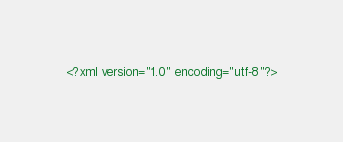<code> <loc_0><loc_0><loc_500><loc_500><_XML_><?xml version="1.0" encoding="utf-8"?></code> 